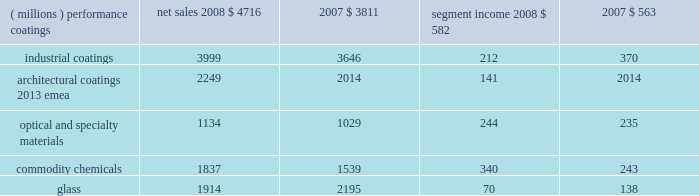Management 2019s discussion and analysis results of reportable business segments net sales segment income ( millions ) 2008 2007 2008 2007 .
Performance coatings sales increased $ 905 million or 24% ( 24 % ) in 2008 .
Sales increased 21% ( 21 % ) due to acquisitions , largely due to the impact of the sigmakalon protective and marine coatings business .
Sales also grew by 3% ( 3 % ) due to higher selling prices and 2% ( 2 % ) due to the positive impact of foreign currency translation .
Sales volumes declined 2% ( 2 % ) as reduced volumes in architectural coatings 2013 americas and asia pacific and automotive refinish were not fully offset by improved volumes in the aerospace and protective and marine businesses .
Volume growth in the aerospace businesses occurred throughout the world , while the volume growth in protective and marine coatings occurred primarily in asia .
Segment income increased $ 19 million in 2008 .
Factors increasing segment income were the positive impact of acquisitions , lower overhead costs and the positive impact of foreign currency translation .
The benefit of higher selling prices more than offset the negative impact of inflation , including higher raw materials and benefit costs .
Segment income was reduced by the impact of the lower sales volumes in architectural coatings and automotive refinish , which more than offset the benefit of volume gains in the aerospace and protective and marine coatings businesses .
Industrial coatings sales increased $ 353 million or 10% ( 10 % ) in 2008 .
Sales increased 11% ( 11 % ) due to acquisitions , including the impact of the sigmakalon industrial coatings business .
Sales also grew 3% ( 3 % ) due to the positive impact of foreign currency translation , and 1% ( 1 % ) from higher selling prices .
Sales volumes declined 5% ( 5 % ) as reduced volumes were experienced in all three businesses , reflecting the substantial declines in global demand .
Volume declines in the automotive and industrial businesses were primarily in the u.s .
And canada .
Additional volume declines in the european and asian regions were experienced by the industrial coatings business .
In packaging coatings , volume declines in europe were only partially offset by gains in asia and north america .
Segment income declined $ 158 million in 2008 due to the lower volumes and inflation , including higher raw material and freight costs , the impact of which was only partially mitigated by the increased selling prices .
Segment income also declined due to higher selling and distribution costs , including higher bad debt expense .
Factors increasing segment income were the earnings of acquired businesses , the positive impact of foreign currency translation and lower manufacturing costs .
Architectural coatings - emea sales for the year were $ 2249 million .
This business was acquired in the sigmakalon acquisition .
Segment income was $ 141 million , which included amortization expense of $ 63 million related to acquired intangible assets and depreciation expense of $ 58 million .
Optical and specialty materials sales increased $ 105 million or 10% ( 10 % ) in 2008 .
Sales increased 5% ( 5 % ) due to higher volumes in our optical products business resulting from the launch of transitions optical 2019s next generation lens product , 3% ( 3 % ) due to the positive impact of foreign currency translation and 2% ( 2 % ) due to increased selling prices .
Segment income increased $ 9 million in 2008 .
The increase in segment income was the result of increased sales volumes and the favorable impact of currency partially offset by increased selling and marketing costs in the optical products business related to the transitions optical product launch mentioned above .
Increased selling prices only partially offset higher raw material costs , primarily in our silicas business .
Commodity chemicals sales increased $ 298 million or 19% ( 19 % ) in 2008 .
Sales increased 18% ( 18 % ) due to higher selling prices and 1% ( 1 % ) due to improved sales volumes .
Segment income increased $ 97 million in 2008 .
Segment income increased in large part due to higher selling prices , which more than offset the negative impact of inflation , primarily higher raw material and energy costs .
Segment income also improved due to lower manufacturing costs , while lower margin mix and equity earnings reduced segment income .
Glass sales decreased $ 281 million or 13% ( 13 % ) in 2008 .
Sales decreased 11% ( 11 % ) due to the divestiture of the automotive glass and services business in september 2008 and 4% ( 4 % ) due to lower sales volumes .
Sales increased 2% ( 2 % ) due to higher selling prices .
Segment income decreased $ 68 million in 2008 .
Segment income decreased due to the divestiture of the automotive glass and services business , lower volumes , the negative impact of inflation and lower equity earnings from our asian fiber glass joint ventures .
Factors increasing segment income were lower manufacturing costs , higher selling prices and stronger foreign currency .
Outlook overall global economic activity was volatile in 2008 with an overall downward trend .
The north american economy continued a slowing trend which began during the second half of 2006 and continued all of 2007 .
The impact of the weakening u.s .
Economy was particularly 2008 ppg annual report and form 10-k 17 .
Without the foreign currency translation gain , what would 2008 sales have been in the performance coatings segment , in millions?\\n? 
Computations: (4716 - (3811 * 2%))
Answer: 4639.78. 